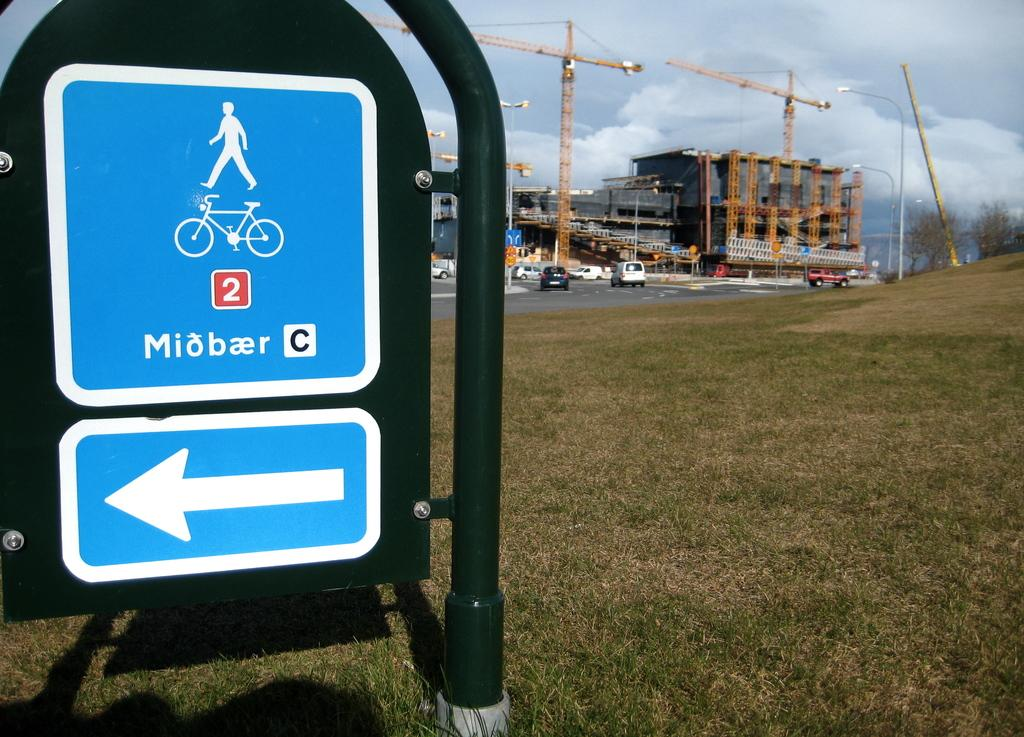<image>
Render a clear and concise summary of the photo. a blue sign with the letter C on it 